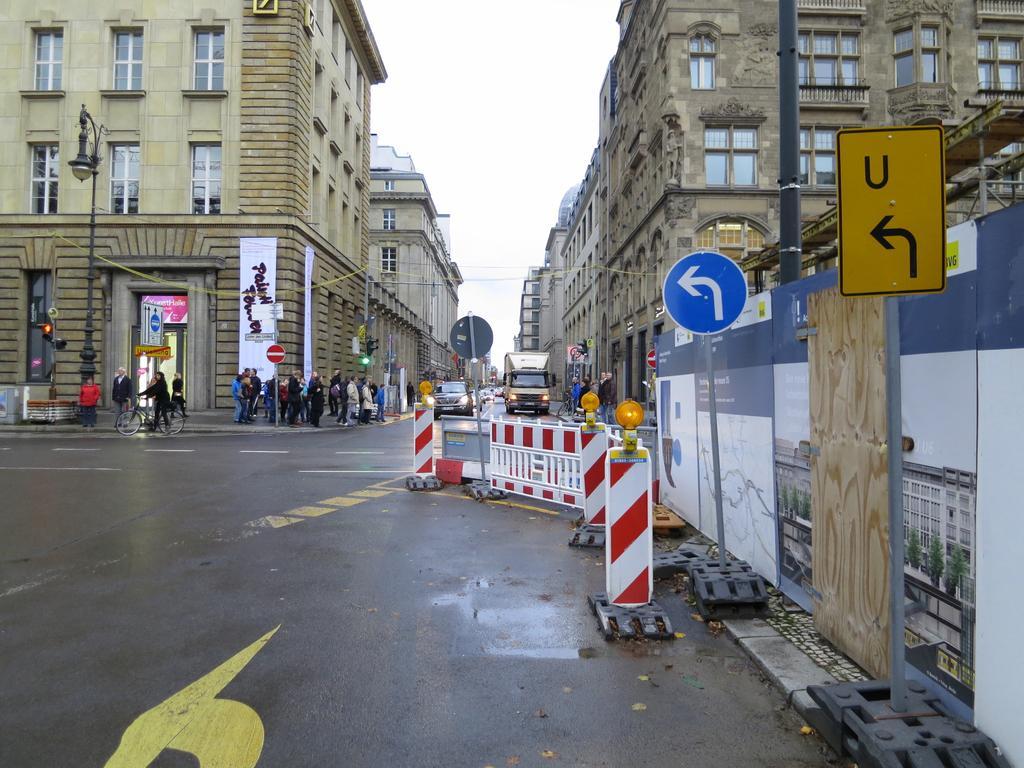Could you give a brief overview of what you see in this image? In this image I can see the road, few traffic stands, few boards, few poles, few vehicles on the road, few persons on the sidewalk, few buildings and in the background I can see the sky. 